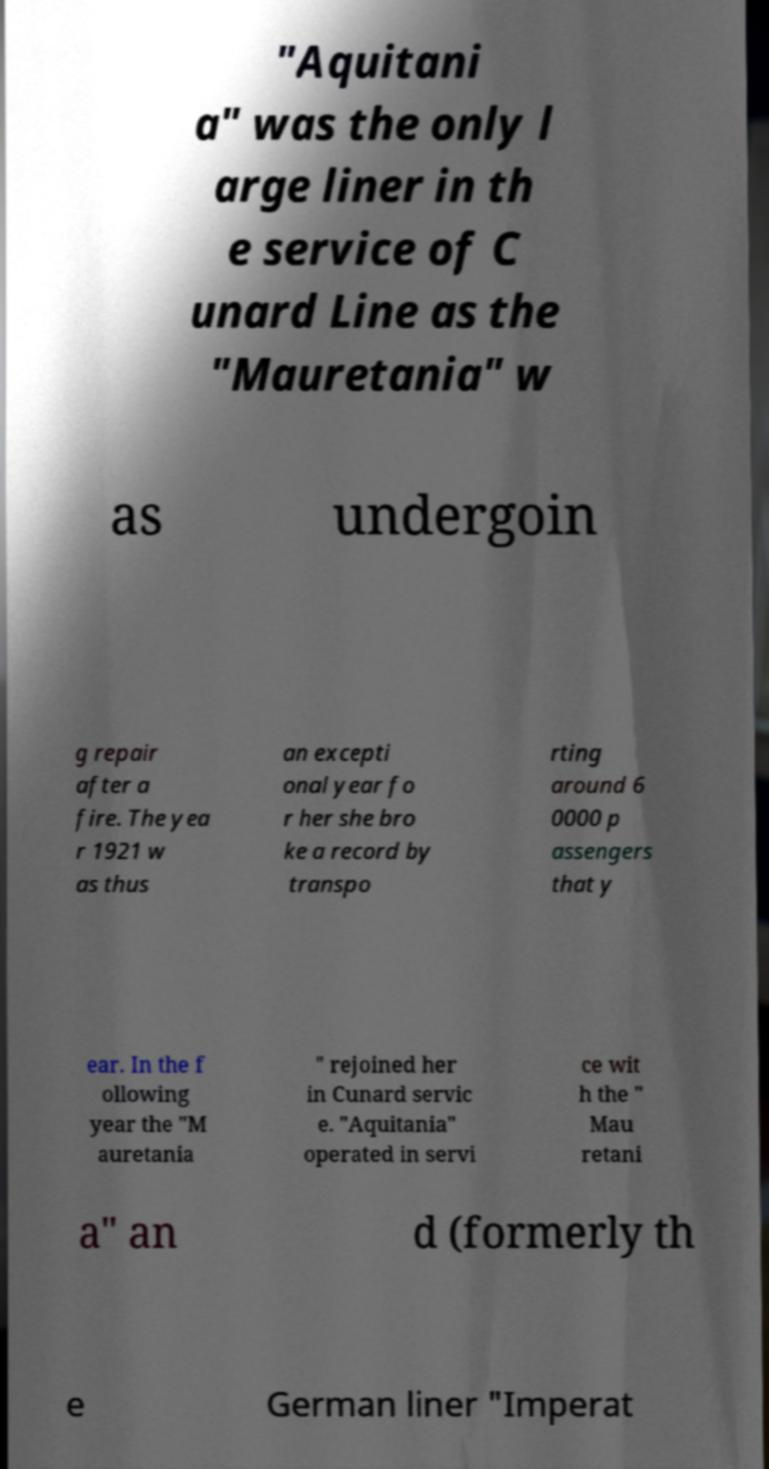I need the written content from this picture converted into text. Can you do that? "Aquitani a" was the only l arge liner in th e service of C unard Line as the "Mauretania" w as undergoin g repair after a fire. The yea r 1921 w as thus an excepti onal year fo r her she bro ke a record by transpo rting around 6 0000 p assengers that y ear. In the f ollowing year the "M auretania " rejoined her in Cunard servic e. "Aquitania" operated in servi ce wit h the " Mau retani a" an d (formerly th e German liner "Imperat 